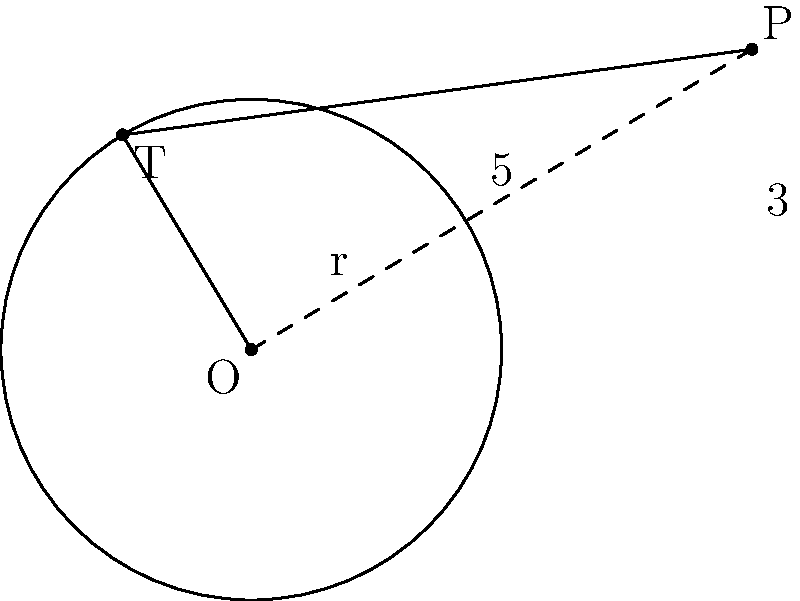In the diagram, O is the center of a circle with radius r = 2.5 units. Point P is located at coordinates (5, 3) relative to O. A tangent line is drawn from P to the circle, touching it at point T. Calculate the length of the tangent line PT. Let's solve this step-by-step:

1) In a right-angled triangle OPT:
   - OP is the hypotenuse
   - OT is the radius (r = 2.5)
   - PT is the tangent line we need to find

2) We can use the Pythagorean theorem: $OP^2 = OT^2 + PT^2$

3) First, let's find OP:
   $OP = \sqrt{5^2 + 3^2} = \sqrt{25 + 9} = \sqrt{34}$

4) Now we can set up our equation:
   $(\sqrt{34})^2 = 2.5^2 + PT^2$

5) Simplify:
   $34 = 6.25 + PT^2$

6) Solve for PT:
   $PT^2 = 34 - 6.25 = 27.75$
   $PT = \sqrt{27.75} = 5.27$ (rounded to two decimal places)

Therefore, the length of the tangent line PT is approximately 5.27 units.
Answer: $5.27$ units 